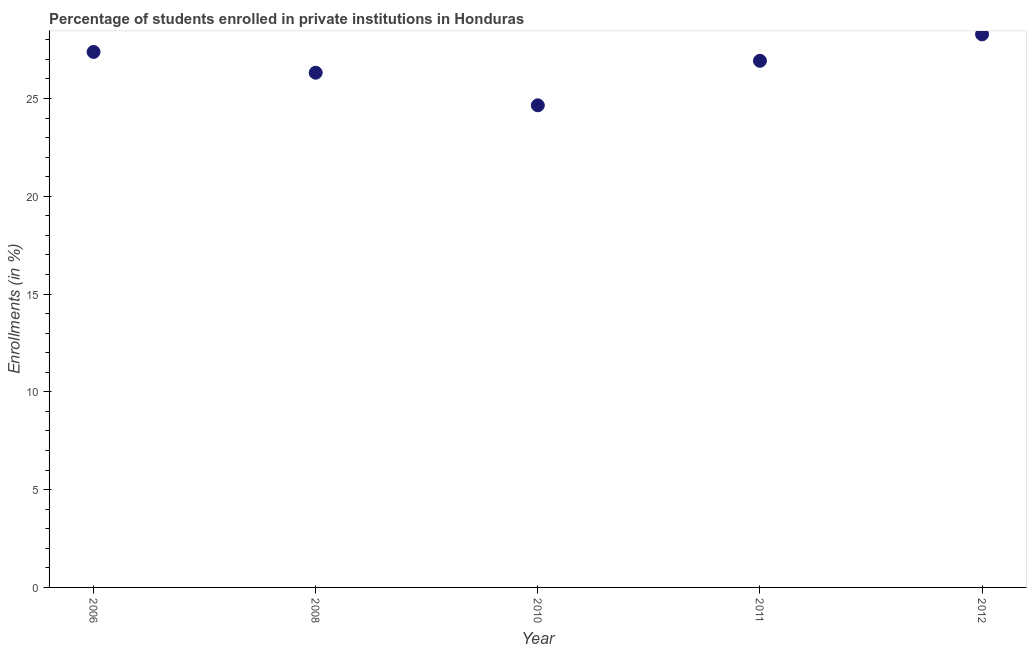What is the enrollments in private institutions in 2011?
Offer a terse response. 26.93. Across all years, what is the maximum enrollments in private institutions?
Keep it short and to the point. 28.28. Across all years, what is the minimum enrollments in private institutions?
Ensure brevity in your answer.  24.65. In which year was the enrollments in private institutions maximum?
Ensure brevity in your answer.  2012. What is the sum of the enrollments in private institutions?
Your answer should be compact. 133.54. What is the difference between the enrollments in private institutions in 2006 and 2011?
Provide a short and direct response. 0.45. What is the average enrollments in private institutions per year?
Your answer should be compact. 26.71. What is the median enrollments in private institutions?
Provide a short and direct response. 26.93. In how many years, is the enrollments in private institutions greater than 15 %?
Offer a very short reply. 5. What is the ratio of the enrollments in private institutions in 2008 to that in 2012?
Provide a succinct answer. 0.93. What is the difference between the highest and the second highest enrollments in private institutions?
Ensure brevity in your answer.  0.9. Is the sum of the enrollments in private institutions in 2006 and 2012 greater than the maximum enrollments in private institutions across all years?
Make the answer very short. Yes. What is the difference between the highest and the lowest enrollments in private institutions?
Offer a very short reply. 3.63. Does the enrollments in private institutions monotonically increase over the years?
Provide a short and direct response. No. Does the graph contain any zero values?
Give a very brief answer. No. Does the graph contain grids?
Your answer should be very brief. No. What is the title of the graph?
Provide a short and direct response. Percentage of students enrolled in private institutions in Honduras. What is the label or title of the X-axis?
Make the answer very short. Year. What is the label or title of the Y-axis?
Offer a very short reply. Enrollments (in %). What is the Enrollments (in %) in 2006?
Keep it short and to the point. 27.38. What is the Enrollments (in %) in 2008?
Offer a very short reply. 26.32. What is the Enrollments (in %) in 2010?
Offer a terse response. 24.65. What is the Enrollments (in %) in 2011?
Give a very brief answer. 26.93. What is the Enrollments (in %) in 2012?
Offer a very short reply. 28.28. What is the difference between the Enrollments (in %) in 2006 and 2008?
Offer a terse response. 1.06. What is the difference between the Enrollments (in %) in 2006 and 2010?
Your answer should be very brief. 2.73. What is the difference between the Enrollments (in %) in 2006 and 2011?
Offer a terse response. 0.45. What is the difference between the Enrollments (in %) in 2006 and 2012?
Provide a succinct answer. -0.9. What is the difference between the Enrollments (in %) in 2008 and 2010?
Offer a terse response. 1.67. What is the difference between the Enrollments (in %) in 2008 and 2011?
Offer a terse response. -0.61. What is the difference between the Enrollments (in %) in 2008 and 2012?
Provide a succinct answer. -1.96. What is the difference between the Enrollments (in %) in 2010 and 2011?
Offer a very short reply. -2.28. What is the difference between the Enrollments (in %) in 2010 and 2012?
Provide a short and direct response. -3.63. What is the difference between the Enrollments (in %) in 2011 and 2012?
Offer a very short reply. -1.35. What is the ratio of the Enrollments (in %) in 2006 to that in 2008?
Make the answer very short. 1.04. What is the ratio of the Enrollments (in %) in 2006 to that in 2010?
Your response must be concise. 1.11. What is the ratio of the Enrollments (in %) in 2006 to that in 2012?
Keep it short and to the point. 0.97. What is the ratio of the Enrollments (in %) in 2008 to that in 2010?
Provide a succinct answer. 1.07. What is the ratio of the Enrollments (in %) in 2010 to that in 2011?
Provide a succinct answer. 0.92. What is the ratio of the Enrollments (in %) in 2010 to that in 2012?
Your answer should be compact. 0.87. 